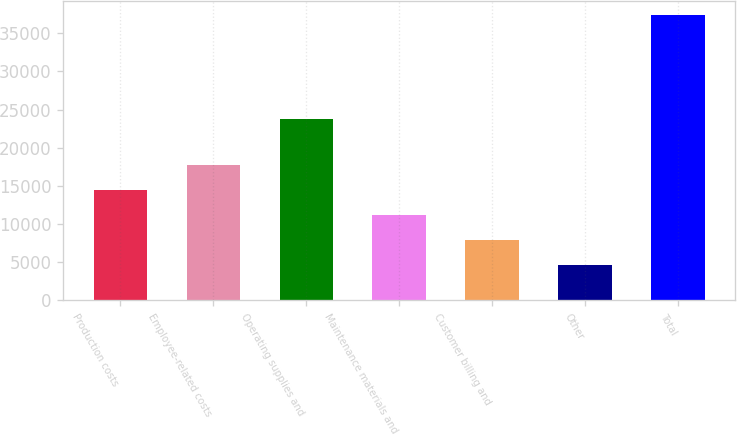<chart> <loc_0><loc_0><loc_500><loc_500><bar_chart><fcel>Production costs<fcel>Employee-related costs<fcel>Operating supplies and<fcel>Maintenance materials and<fcel>Customer billing and<fcel>Other<fcel>Total<nl><fcel>14505.3<fcel>17772.4<fcel>23732<fcel>11238.2<fcel>7971.1<fcel>4704<fcel>37375<nl></chart> 